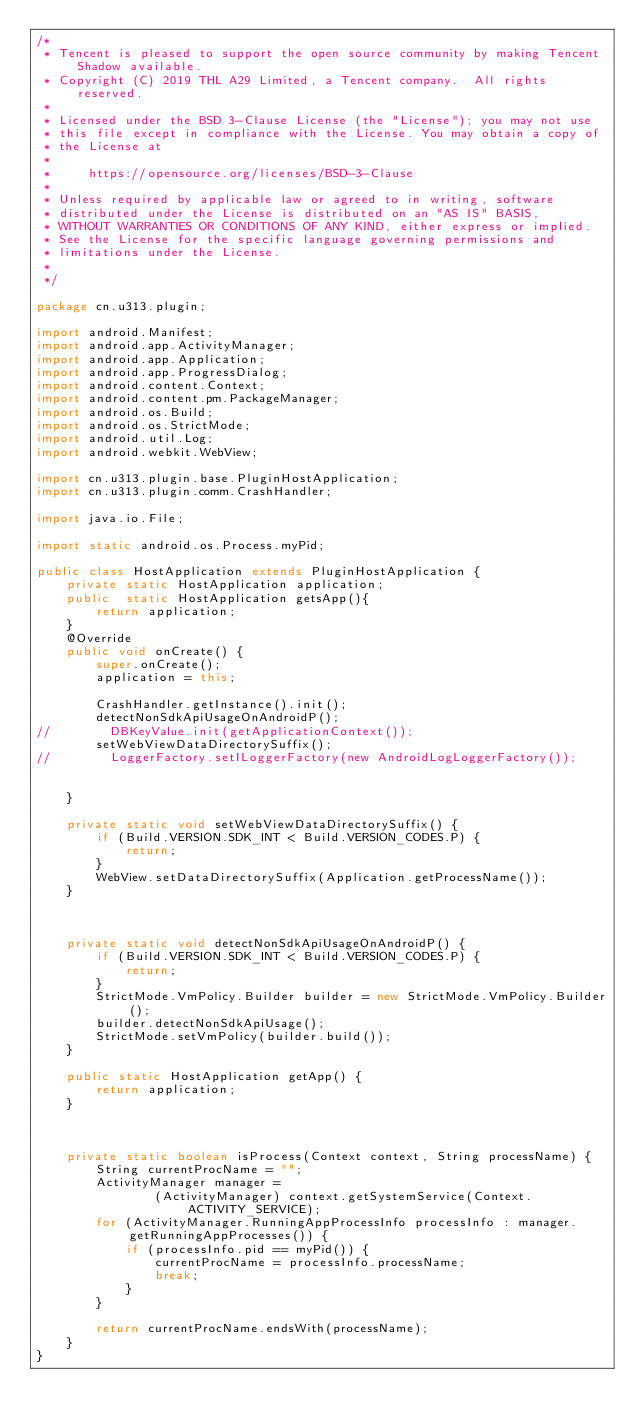Convert code to text. <code><loc_0><loc_0><loc_500><loc_500><_Java_>/*
 * Tencent is pleased to support the open source community by making Tencent Shadow available.
 * Copyright (C) 2019 THL A29 Limited, a Tencent company.  All rights reserved.
 *
 * Licensed under the BSD 3-Clause License (the "License"); you may not use
 * this file except in compliance with the License. You may obtain a copy of
 * the License at
 *
 *     https://opensource.org/licenses/BSD-3-Clause
 *
 * Unless required by applicable law or agreed to in writing, software
 * distributed under the License is distributed on an "AS IS" BASIS,
 * WITHOUT WARRANTIES OR CONDITIONS OF ANY KIND, either express or implied.
 * See the License for the specific language governing permissions and
 * limitations under the License.
 *
 */

package cn.u313.plugin;

import android.Manifest;
import android.app.ActivityManager;
import android.app.Application;
import android.app.ProgressDialog;
import android.content.Context;
import android.content.pm.PackageManager;
import android.os.Build;
import android.os.StrictMode;
import android.util.Log;
import android.webkit.WebView;

import cn.u313.plugin.base.PluginHostApplication;
import cn.u313.plugin.comm.CrashHandler;

import java.io.File;

import static android.os.Process.myPid;

public class HostApplication extends PluginHostApplication {
    private static HostApplication application;
    public  static HostApplication getsApp(){
        return application;
    }
    @Override
    public void onCreate() {
        super.onCreate();
        application = this;

        CrashHandler.getInstance().init();
        detectNonSdkApiUsageOnAndroidP();
//        DBKeyValue.init(getApplicationContext());
        setWebViewDataDirectorySuffix();
//        LoggerFactory.setILoggerFactory(new AndroidLogLoggerFactory());


    }

    private static void setWebViewDataDirectorySuffix() {
        if (Build.VERSION.SDK_INT < Build.VERSION_CODES.P) {
            return;
        }
        WebView.setDataDirectorySuffix(Application.getProcessName());
    }



    private static void detectNonSdkApiUsageOnAndroidP() {
        if (Build.VERSION.SDK_INT < Build.VERSION_CODES.P) {
            return;
        }
        StrictMode.VmPolicy.Builder builder = new StrictMode.VmPolicy.Builder();
        builder.detectNonSdkApiUsage();
        StrictMode.setVmPolicy(builder.build());
    }

    public static HostApplication getApp() {
        return application;
    }



    private static boolean isProcess(Context context, String processName) {
        String currentProcName = "";
        ActivityManager manager =
                (ActivityManager) context.getSystemService(Context.ACTIVITY_SERVICE);
        for (ActivityManager.RunningAppProcessInfo processInfo : manager.getRunningAppProcesses()) {
            if (processInfo.pid == myPid()) {
                currentProcName = processInfo.processName;
                break;
            }
        }

        return currentProcName.endsWith(processName);
    }
}
</code> 